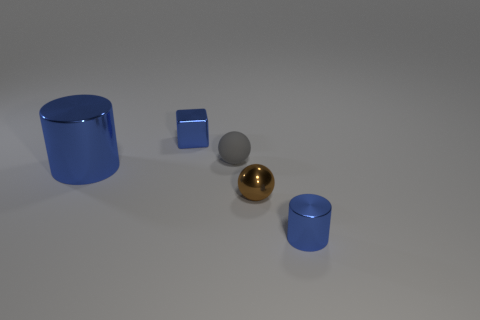What is the color of the big thing that is made of the same material as the blue cube?
Provide a succinct answer. Blue. Does the gray ball have the same size as the brown object?
Make the answer very short. Yes. What is the small blue block made of?
Provide a succinct answer. Metal. There is a block that is the same size as the matte object; what is its material?
Provide a short and direct response. Metal. Is there a purple metal ball that has the same size as the rubber sphere?
Keep it short and to the point. No. Is the number of small brown metal objects to the left of the metallic sphere the same as the number of small blue metal cubes to the left of the metallic block?
Ensure brevity in your answer.  Yes. Is the number of tiny brown shiny balls greater than the number of small shiny things?
Your answer should be very brief. No. What number of shiny objects are green cylinders or large blue cylinders?
Offer a very short reply. 1. What number of small balls are the same color as the small metal block?
Ensure brevity in your answer.  0. What material is the blue thing behind the blue cylinder to the left of the tiny blue object in front of the large blue cylinder made of?
Keep it short and to the point. Metal. 